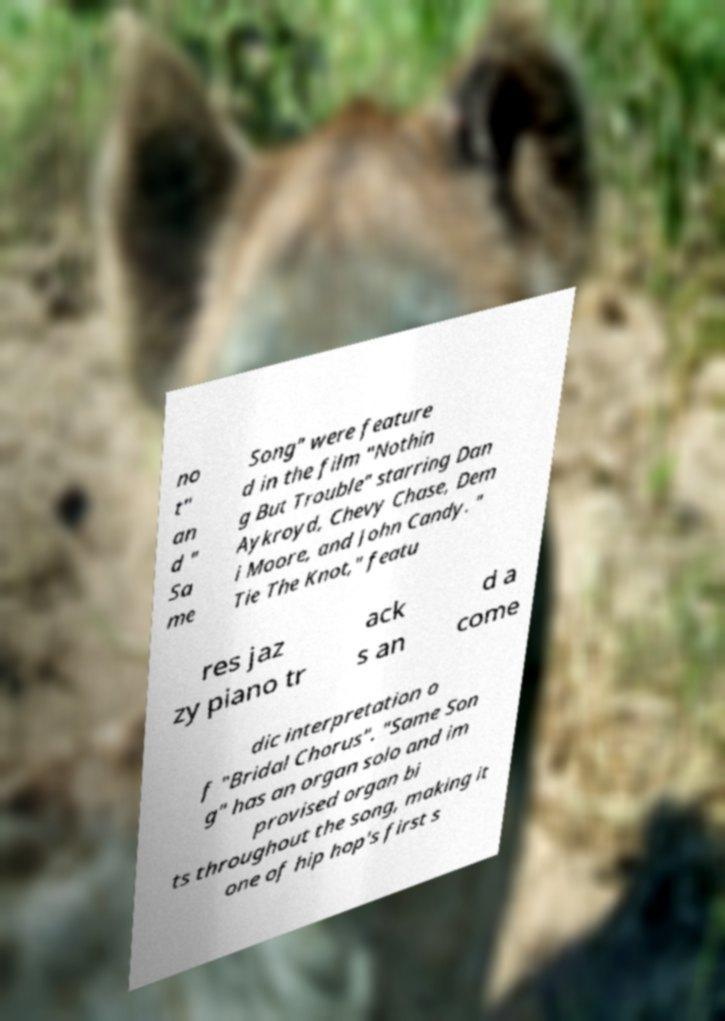Please read and relay the text visible in this image. What does it say? no t" an d " Sa me Song" were feature d in the film "Nothin g But Trouble" starring Dan Aykroyd, Chevy Chase, Dem i Moore, and John Candy. " Tie The Knot," featu res jaz zy piano tr ack s an d a come dic interpretation o f "Bridal Chorus". "Same Son g" has an organ solo and im provised organ bi ts throughout the song, making it one of hip hop's first s 